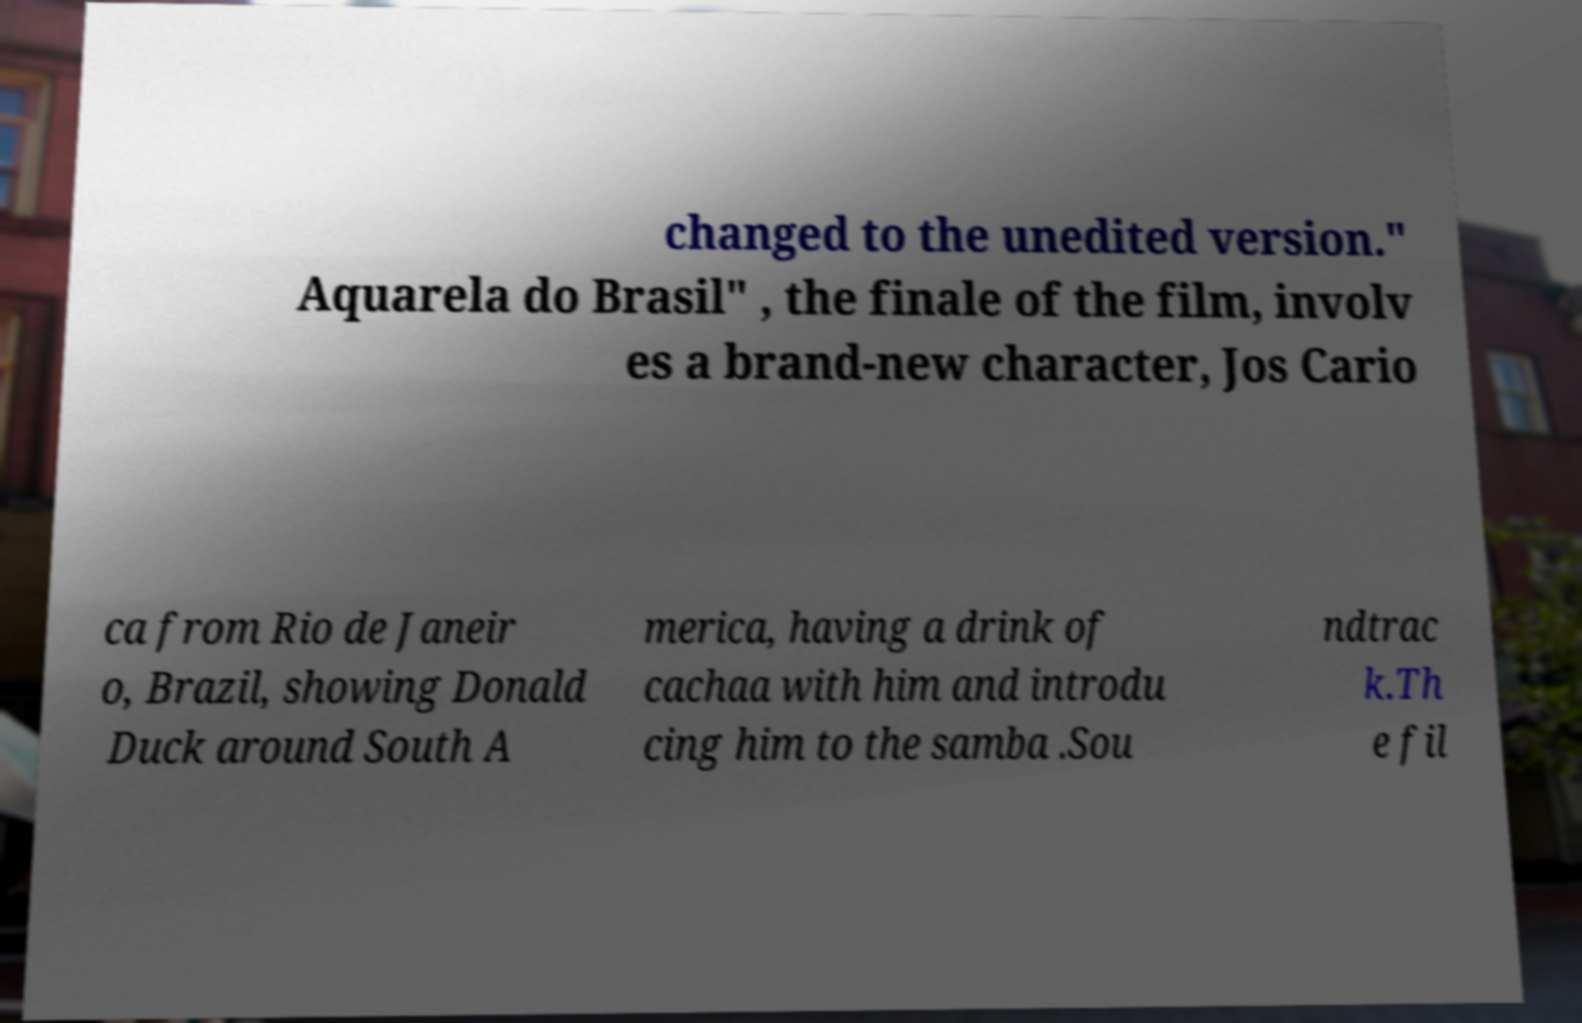I need the written content from this picture converted into text. Can you do that? changed to the unedited version." Aquarela do Brasil" , the finale of the film, involv es a brand-new character, Jos Cario ca from Rio de Janeir o, Brazil, showing Donald Duck around South A merica, having a drink of cachaa with him and introdu cing him to the samba .Sou ndtrac k.Th e fil 